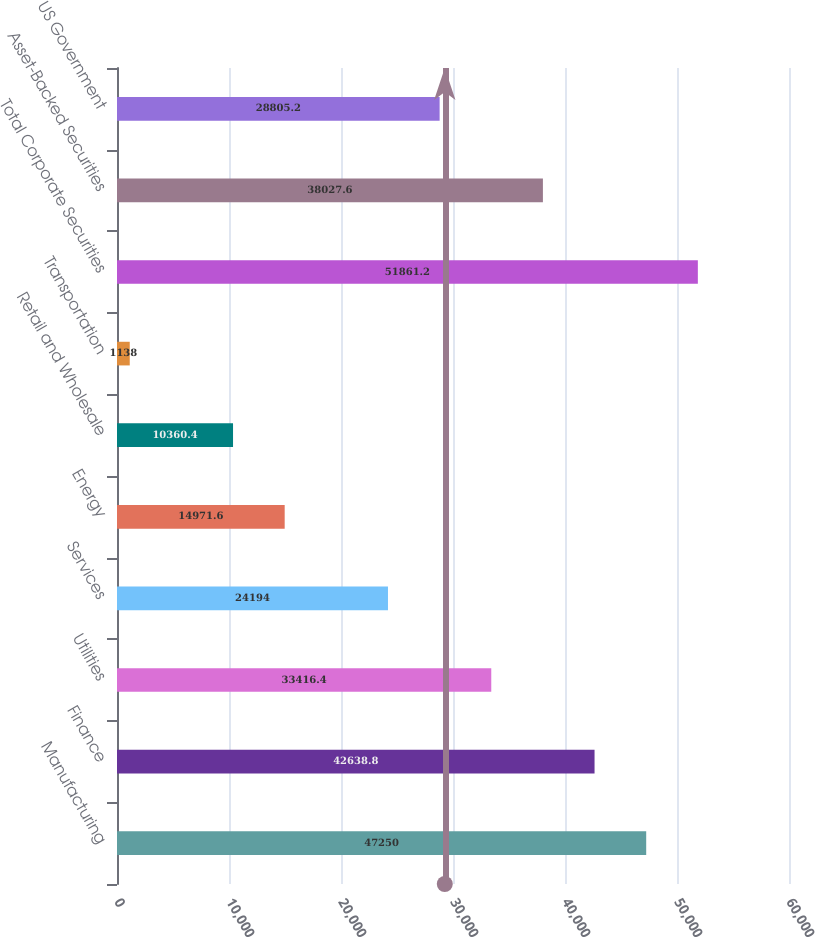Convert chart to OTSL. <chart><loc_0><loc_0><loc_500><loc_500><bar_chart><fcel>Manufacturing<fcel>Finance<fcel>Utilities<fcel>Services<fcel>Energy<fcel>Retail and Wholesale<fcel>Transportation<fcel>Total Corporate Securities<fcel>Asset-Backed Securities<fcel>US Government<nl><fcel>47250<fcel>42638.8<fcel>33416.4<fcel>24194<fcel>14971.6<fcel>10360.4<fcel>1138<fcel>51861.2<fcel>38027.6<fcel>28805.2<nl></chart> 